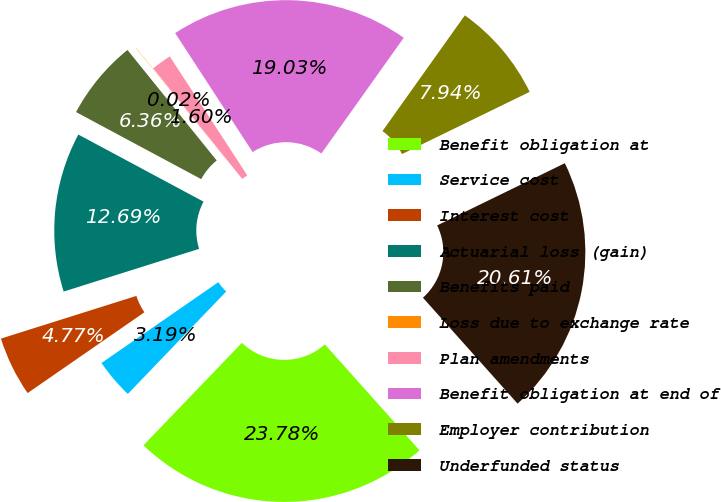Convert chart. <chart><loc_0><loc_0><loc_500><loc_500><pie_chart><fcel>Benefit obligation at<fcel>Service cost<fcel>Interest cost<fcel>Actuarial loss (gain)<fcel>Benefits paid<fcel>Loss due to exchange rate<fcel>Plan amendments<fcel>Benefit obligation at end of<fcel>Employer contribution<fcel>Underfunded status<nl><fcel>23.78%<fcel>3.19%<fcel>4.77%<fcel>12.69%<fcel>6.36%<fcel>0.02%<fcel>1.6%<fcel>19.03%<fcel>7.94%<fcel>20.61%<nl></chart> 